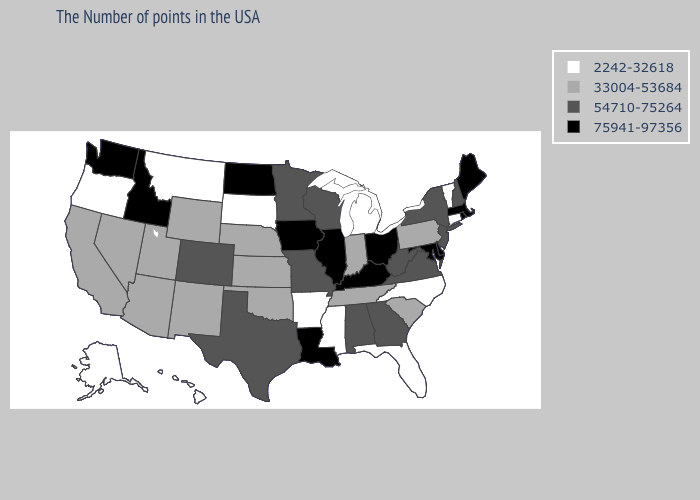What is the value of Florida?
Short answer required. 2242-32618. Does Hawaii have the lowest value in the USA?
Quick response, please. Yes. Which states have the highest value in the USA?
Write a very short answer. Maine, Massachusetts, Rhode Island, Delaware, Maryland, Ohio, Kentucky, Illinois, Louisiana, Iowa, North Dakota, Idaho, Washington. What is the highest value in the USA?
Keep it brief. 75941-97356. What is the value of California?
Be succinct. 33004-53684. Which states have the lowest value in the West?
Give a very brief answer. Montana, Oregon, Alaska, Hawaii. What is the highest value in the USA?
Short answer required. 75941-97356. What is the lowest value in the USA?
Quick response, please. 2242-32618. Does the map have missing data?
Write a very short answer. No. Among the states that border Michigan , which have the highest value?
Give a very brief answer. Ohio. Does Louisiana have the highest value in the South?
Quick response, please. Yes. What is the value of Pennsylvania?
Be succinct. 33004-53684. Name the states that have a value in the range 75941-97356?
Give a very brief answer. Maine, Massachusetts, Rhode Island, Delaware, Maryland, Ohio, Kentucky, Illinois, Louisiana, Iowa, North Dakota, Idaho, Washington. Among the states that border South Carolina , which have the highest value?
Short answer required. Georgia. Does California have the highest value in the USA?
Give a very brief answer. No. 